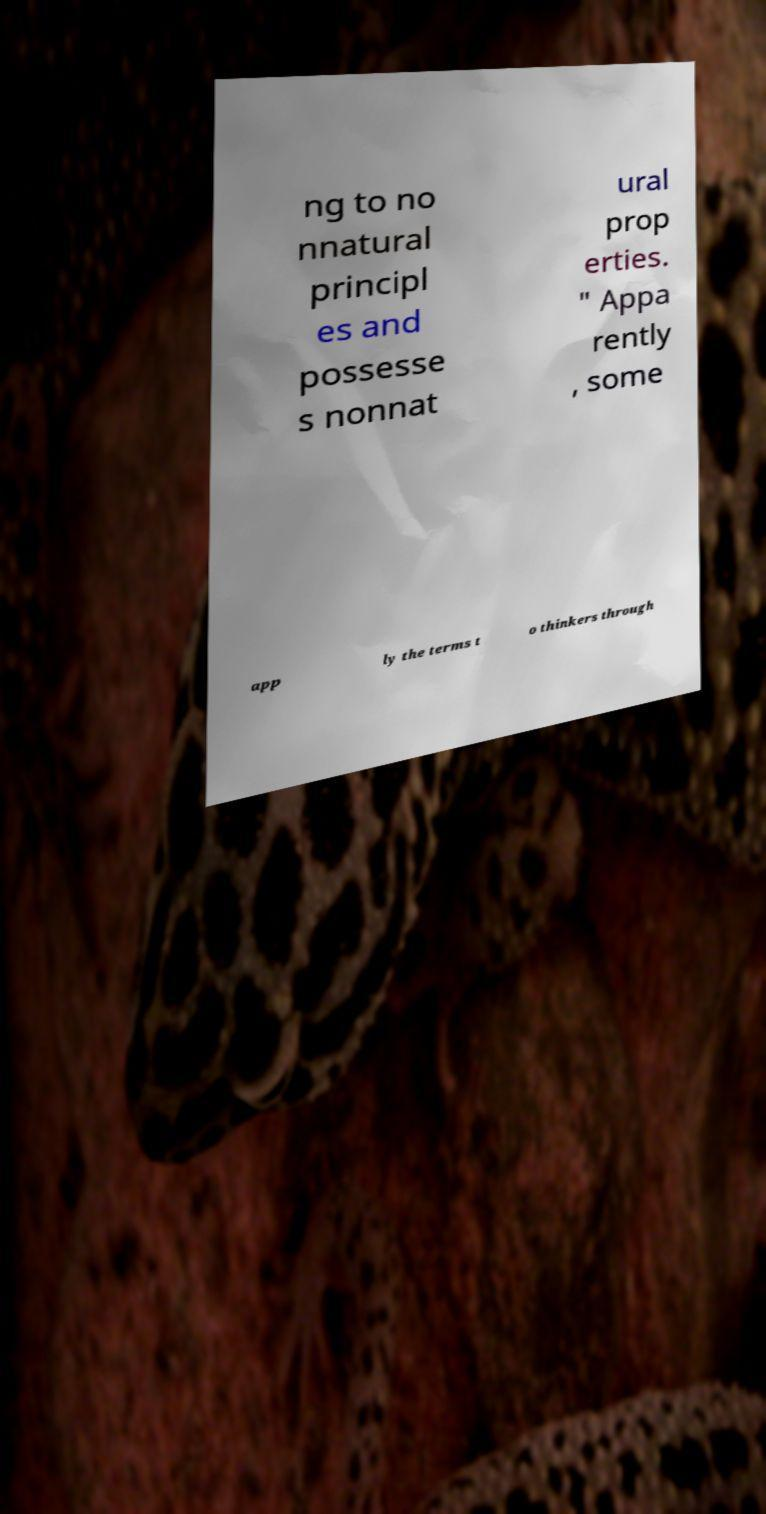For documentation purposes, I need the text within this image transcribed. Could you provide that? ng to no nnatural principl es and possesse s nonnat ural prop erties. " Appa rently , some app ly the terms t o thinkers through 